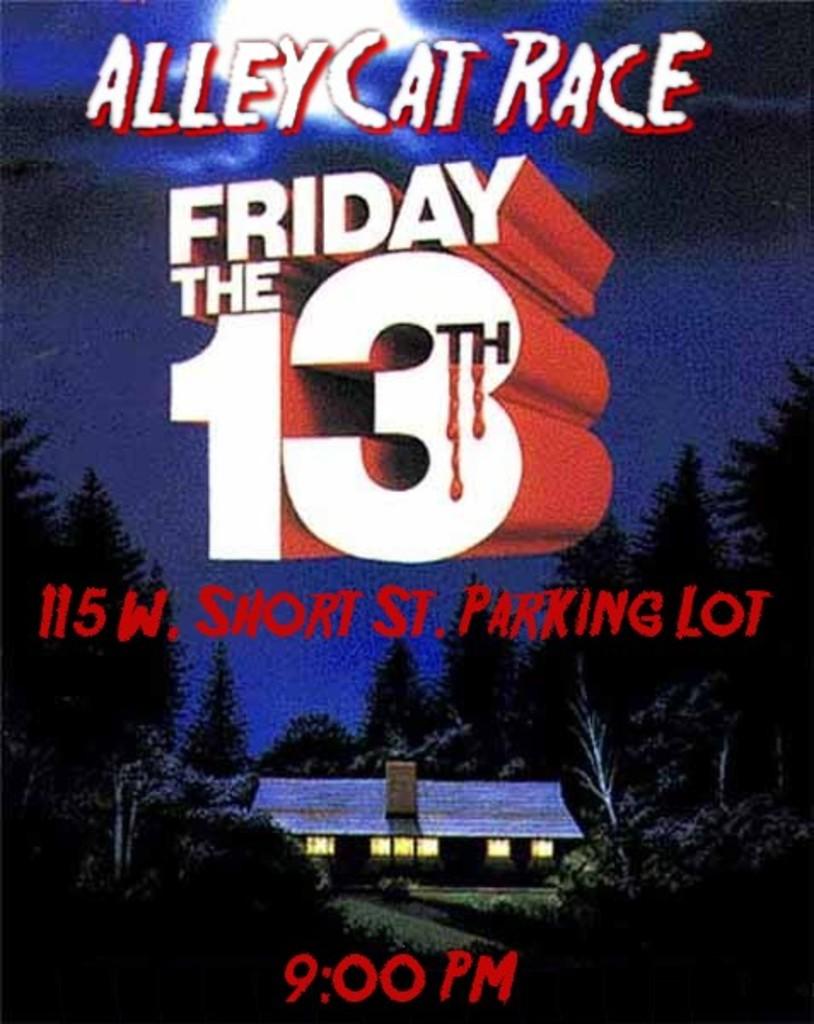When is the race?
Provide a short and direct response. Friday the 13th. Whats is the title of the race?
Keep it short and to the point. Alley cat race. 